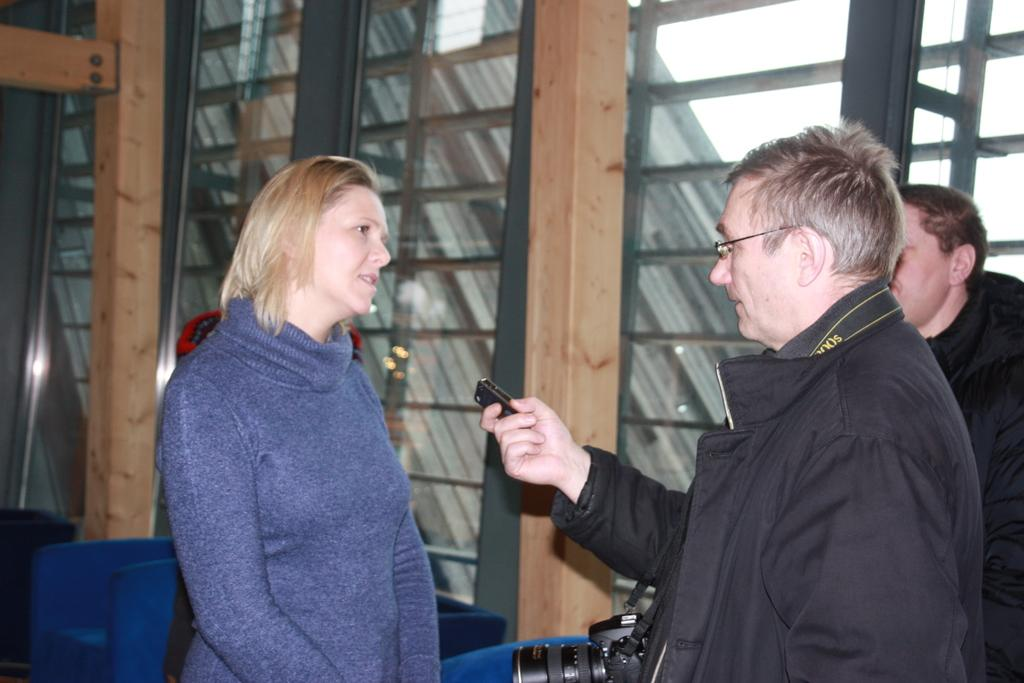What is happening in the image? There are people standing in the image. Can you describe the attire of one of the individuals? One person is wearing a camera. How can you tell that the person holding the object is likely the same person wearing the camera? The person holding the object is likely to be the same person wearing the camera. What can be seen in the background of the image? There are glass windows in the background of the image, and the sky is visible through the windows. What type of net can be seen in the image? There is no net present in the image. How many geese are visible through the windows in the image? There are no geese visible through the windows in the image. 